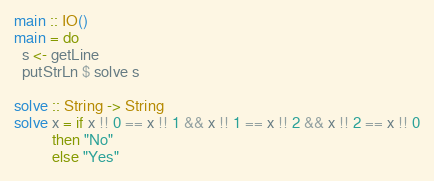<code> <loc_0><loc_0><loc_500><loc_500><_Haskell_>main :: IO()
main = do
  s <- getLine
  putStrLn $ solve s

solve :: String -> String
solve x = if x !! 0 == x !! 1 && x !! 1 == x !! 2 && x !! 2 == x !! 0
          then "No"
          else "Yes"</code> 